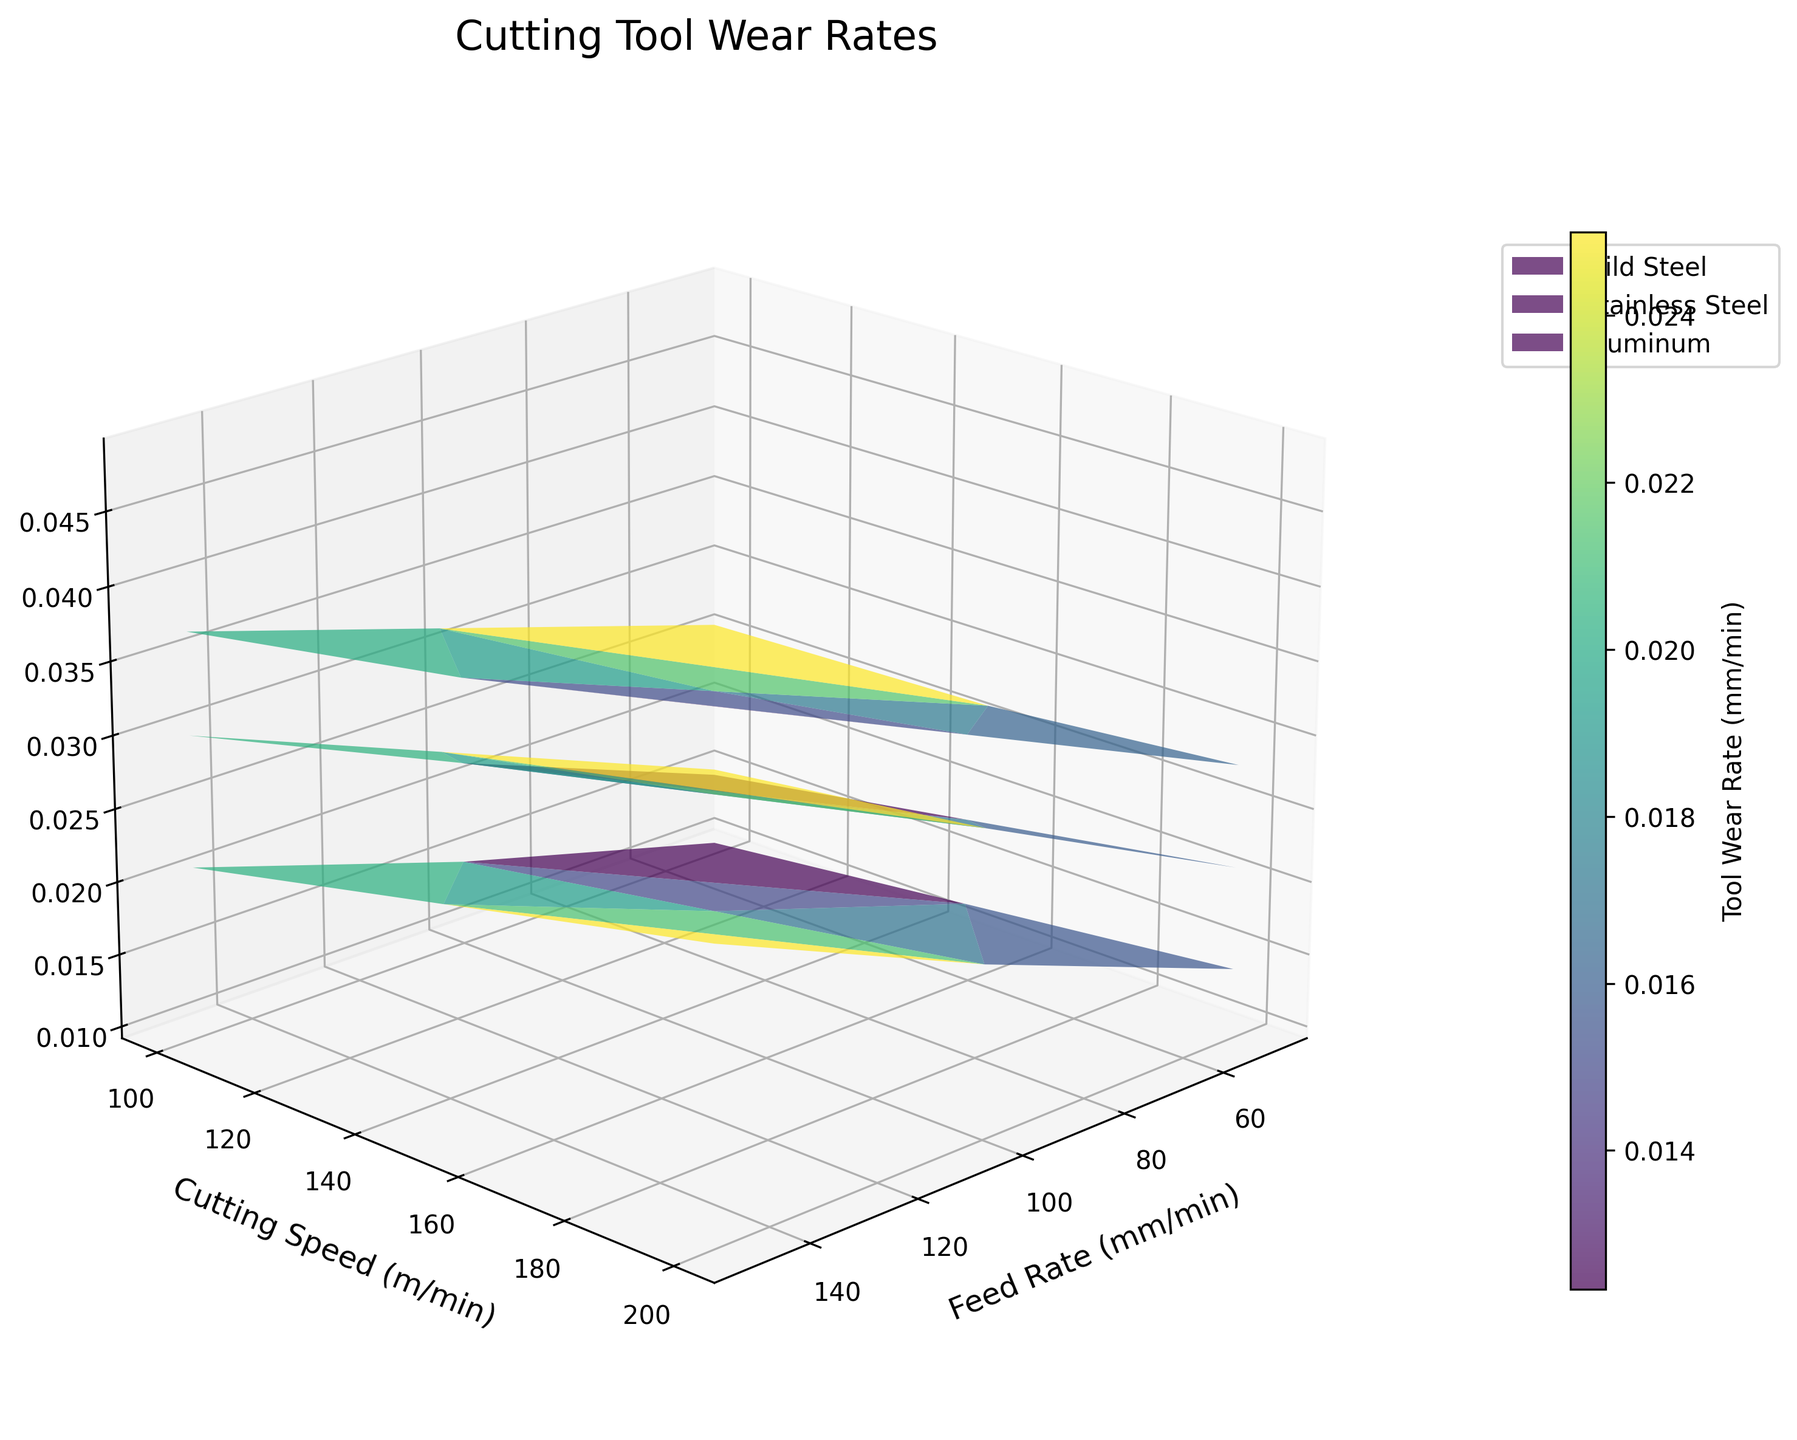What's the title of the plot? The title of the plot is typically located at the top center of the figure and usually set in a slightly larger font size for prominence.
Answer: Cutting Tool Wear Rates What are the labels of the axes? The labels of the axes are written along the corresponding axes in the figure. For this plot, the x-axis label is "Feed Rate (mm/min)", the y-axis label is "Cutting Speed (m/min)", and the z-axis label is "Tool Wear Rate (mm/min)".
Answer: x: Feed Rate (mm/min), y: Cutting Speed (m/min), z: Tool Wear Rate (mm/min) Which metal type tends to show the highest tool wear rate overall? By examining the different surfaces on the plot, the highest regions are typically those with the steepest slopes or highest peaks. Observing these characteristics, Stainless Steel often exhibits the highest tool wear rate compared to Mild Steel and Aluminum.
Answer: Stainless Steel How does the tool wear rate for Mild Steel change as the feed rate increases while keeping the cutting speed constant at 100 m/min? To answer this, look at the section of the plot corresponding to Mild Steel and find the tool wear rates at a cutting speed of 100 m/min. As the feed rate increases from 50 mm/min to 150 mm/min, the tool wear rate increases from 0.015 to 0.030 mm/min.
Answer: It increases Is there a noticeable difference in the color gradient for Aluminum compared to Mild Steel and Stainless Steel? The color gradient in a 3D surface plot indicates the variation in the z-values. Aluminum generally has a lighter color gradient indicating lower tool wear rates compared to the darker gradients seen for Mild Steel and Stainless Steel, suggesting less tool wear for Aluminum.
Answer: Yes Which combination of feed rate and cutting speed results in the highest wear rate for Stainless Steel? To answer this, locate the highest point on the Stainless Steel surface on the plot. The highest tool wear rate appears at the combination of the highest feed rate and cutting speed, which is 150 mm/min feed rate and 200 m/min cutting speed, resulting in a tool wear rate of 0.049 mm/min.
Answer: Feed rate: 150 mm/min, Cutting speed: 200 m/min At a cutting speed of 150 m/min, rank the metals from lowest to highest tool wear rate for a feed rate of 100 mm/min. First, locate the values corresponding to a cutting speed of 150 m/min and a feed rate of 100 mm/min for each metal type. The tool wear rates are: Aluminum (0.018 mm/min), Mild Steel (0.026 mm/min), and Stainless Steel (0.033 mm/min). Ranging them from lowest to highest gives: Aluminum, Mild Steel, Stainless Steel.
Answer: Aluminum, Mild Steel, Stainless Steel What does the colorbar represent in this 3D surface plot? The colorbar, typically found alongside the plot, maps colors to the range of z-values in the plot. Here, it represents the Tool Wear Rate in mm/min, showing how the different colors on the plot correspond to the different rates of tool wear.
Answer: Tool Wear Rate (mm/min) For Mild Steel, how does the tool wear rate change with increasing cutting speed while keeping the feed rate constant at 50 mm/min? Observing the Mild Steel data at a fixed feed rate of 50 mm/min while varying the cutting speed from 100 m/min to 200 m/min shows a gradual increase in tool wear rate from 0.015 to 0.021 mm/min.
Answer: It increases 